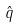Convert formula to latex. <formula><loc_0><loc_0><loc_500><loc_500>\hat { q }</formula> 